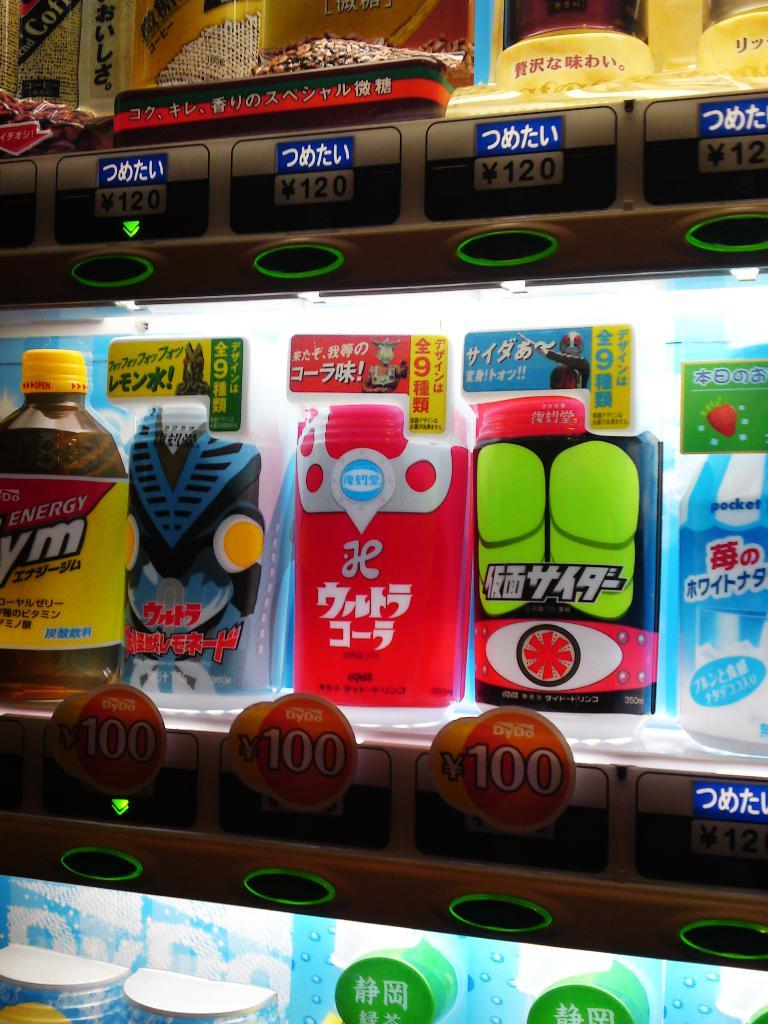What type of structure is present in the image? There are supermarket racks in the image. What can be found on the racks? The racks contain items. How can customers identify the prices of the items? Price tags are attached to the racks. What feature helps to highlight the items on the racks? The racks have lights focused on the items. What type of leather is used to make the car visible in the image? There is no car present in the image, and therefore no leather can be associated with it. 